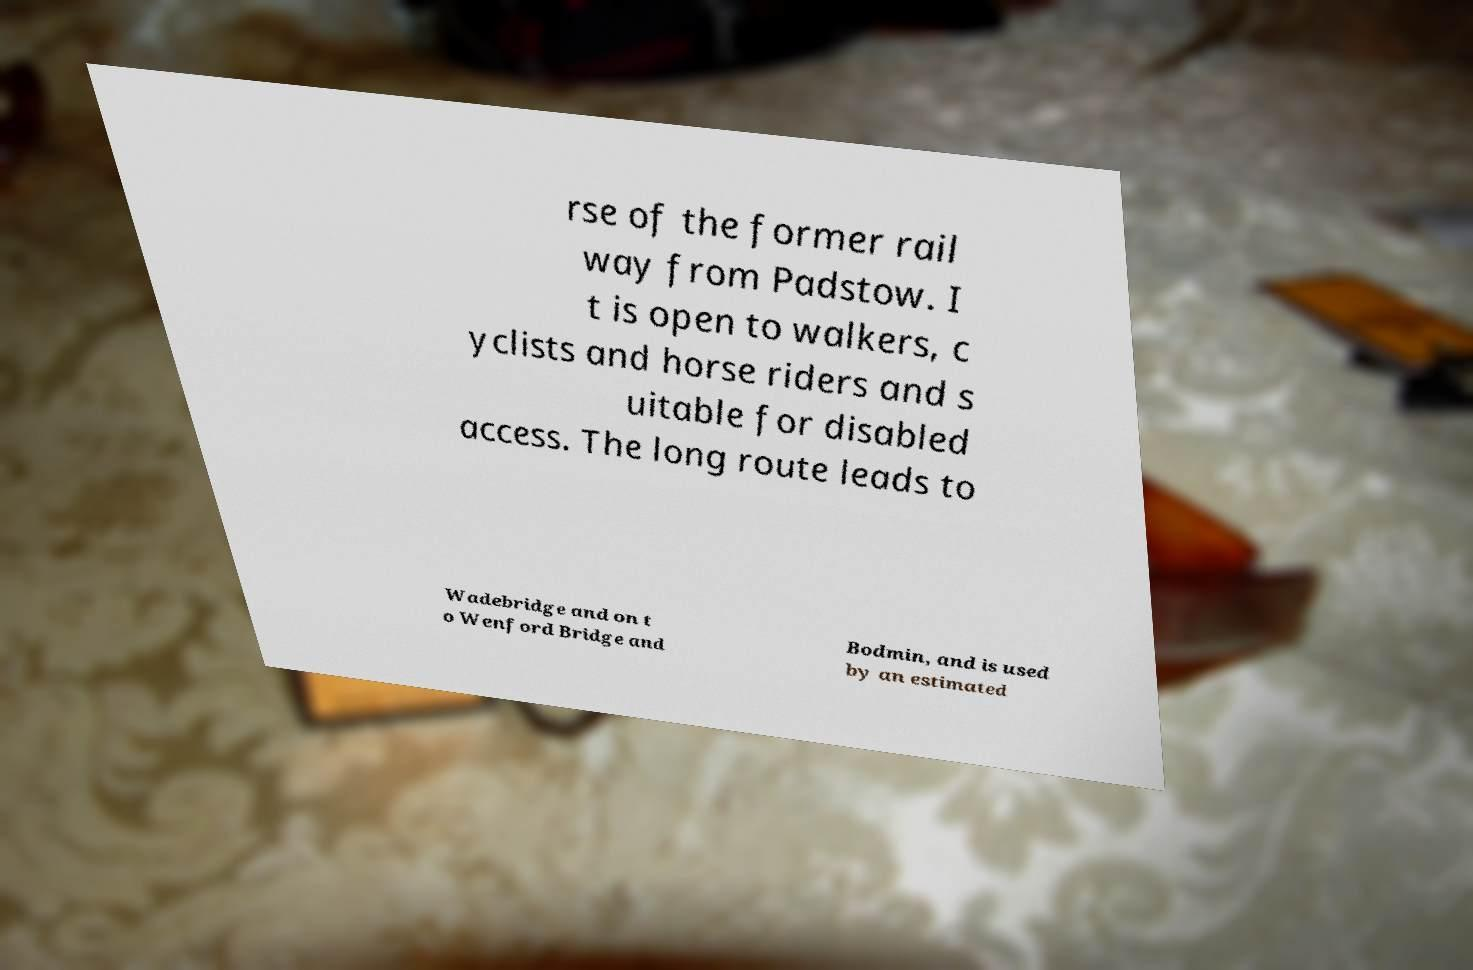Can you accurately transcribe the text from the provided image for me? rse of the former rail way from Padstow. I t is open to walkers, c yclists and horse riders and s uitable for disabled access. The long route leads to Wadebridge and on t o Wenford Bridge and Bodmin, and is used by an estimated 